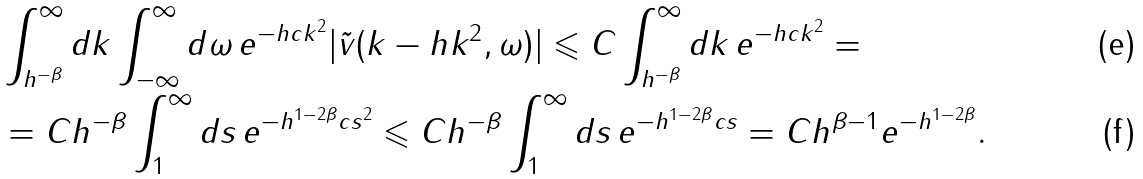Convert formula to latex. <formula><loc_0><loc_0><loc_500><loc_500>& \int _ { h ^ { - \beta } } ^ { \infty } d k \int _ { - \infty } ^ { \infty } d \omega \, e ^ { - h c k ^ { 2 } } | \tilde { v } ( k - h k ^ { 2 } , \omega ) | \leqslant C \int _ { h ^ { - \beta } } ^ { \infty } d k \, e ^ { - h c k ^ { 2 } } = \\ & = C h ^ { - \beta } \int _ { 1 } ^ { \infty } d s \, e ^ { - h ^ { 1 - 2 \beta } c s ^ { 2 } } \leqslant C h ^ { - \beta } \int _ { 1 } ^ { \infty } d s \, e ^ { - h ^ { 1 - 2 \beta } c s } = C h ^ { \beta - 1 } e ^ { - h ^ { 1 - 2 \beta } } .</formula> 